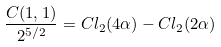Convert formula to latex. <formula><loc_0><loc_0><loc_500><loc_500>\frac { C ( 1 , 1 ) } { 2 ^ { 5 / 2 } } = C l _ { 2 } ( 4 \alpha ) - C l _ { 2 } ( 2 \alpha )</formula> 